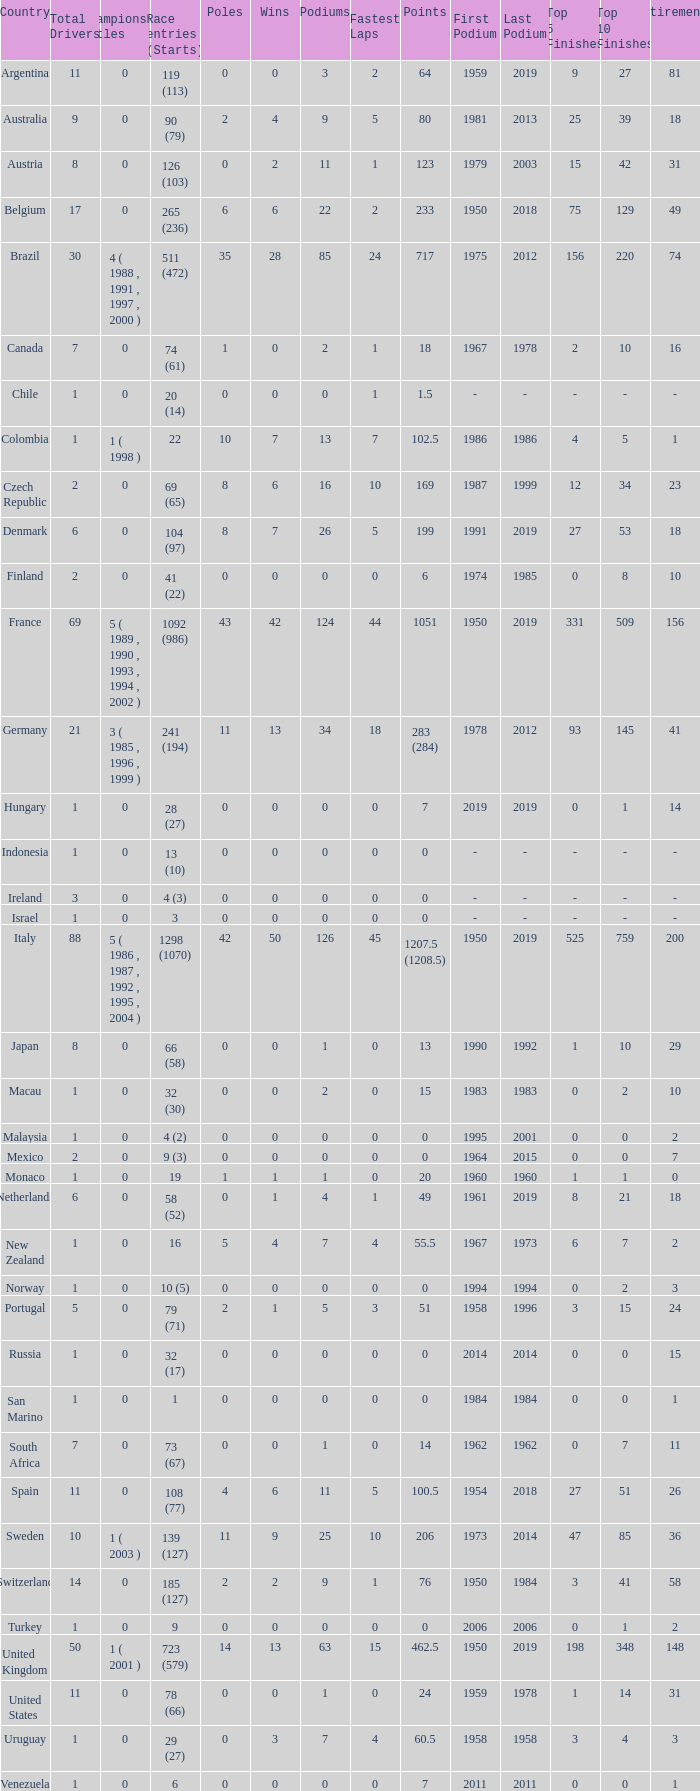How many fastest laps for the nation with 32 (30) entries and starts and fewer than 2 podiums? None. Help me parse the entirety of this table. {'header': ['Country', 'Total Drivers', 'Championship Titles', 'Race entries (Starts)', 'Poles', 'Wins', 'Podiums', 'Fastest Laps', 'Points', 'First Podium', 'Last Podium', 'Top 5 Finishes', 'Top 10 Finishes', 'Retirements'], 'rows': [['Argentina', '11', '0', '119 (113)', '0', '0', '3', '2', '64', '1959', '2019', '9', '27', '81'], ['Australia', '9', '0', '90 (79)', '2', '4', '9', '5', '80', '1981', '2013', '25', '39', '18'], ['Austria', '8', '0', '126 (103)', '0', '2', '11', '1', '123', '1979', '2003', '15', '42', '31'], ['Belgium', '17', '0', '265 (236)', '6', '6', '22', '2', '233', '1950', '2018', '75', '129', '49'], ['Brazil', '30', '4 ( 1988 , 1991 , 1997 , 2000 )', '511 (472)', '35', '28', '85', '24', '717', '1975', '2012', '156', '220', '74'], ['Canada', '7', '0', '74 (61)', '1', '0', '2', '1', '18', '1967', '1978', '2', '10', '16'], ['Chile', '1', '0', '20 (14)', '0', '0', '0', '1', '1.5', '-', '-', '-', '-', '-'], ['Colombia', '1', '1 ( 1998 )', '22', '10', '7', '13', '7', '102.5', '1986', '1986', '4', '5', '1'], ['Czech Republic', '2', '0', '69 (65)', '8', '6', '16', '10', '169', '1987', '1999', '12', '34', '23'], ['Denmark', '6', '0', '104 (97)', '8', '7', '26', '5', '199', '1991', '2019', '27', '53', '18'], ['Finland', '2', '0', '41 (22)', '0', '0', '0', '0', '6', '1974', '1985', '0', '8', '10'], ['France', '69', '5 ( 1989 , 1990 , 1993 , 1994 , 2002 )', '1092 (986)', '43', '42', '124', '44', '1051', '1950', '2019', '331', '509', '156'], ['Germany', '21', '3 ( 1985 , 1996 , 1999 )', '241 (194)', '11', '13', '34', '18', '283 (284)', '1978', '2012', '93', '145', '41'], ['Hungary', '1', '0', '28 (27)', '0', '0', '0', '0', '7', '2019', '2019', '0', '1', '14'], ['Indonesia', '1', '0', '13 (10)', '0', '0', '0', '0', '0', '-', '-', '-', '-', '-'], ['Ireland', '3', '0', '4 (3)', '0', '0', '0', '0', '0', '-', '-', '-', '-', '-'], ['Israel', '1', '0', '3', '0', '0', '0', '0', '0', '-', '-', '-', '-', '-'], ['Italy', '88', '5 ( 1986 , 1987 , 1992 , 1995 , 2004 )', '1298 (1070)', '42', '50', '126', '45', '1207.5 (1208.5)', '1950', '2019', '525', '759', '200'], ['Japan', '8', '0', '66 (58)', '0', '0', '1', '0', '13', '1990', '1992', '1', '10', '29'], ['Macau', '1', '0', '32 (30)', '0', '0', '2', '0', '15', '1983', '1983', '0', '2', '10'], ['Malaysia', '1', '0', '4 (2)', '0', '0', '0', '0', '0', '1995', '2001', '0', '0', '2'], ['Mexico', '2', '0', '9 (3)', '0', '0', '0', '0', '0', '1964', '2015', '0', '0', '7'], ['Monaco', '1', '0', '19', '1', '1', '1', '0', '20', '1960', '1960', '1', '1', '0'], ['Netherlands', '6', '0', '58 (52)', '0', '1', '4', '1', '49', '1961', '2019', '8', '21', '18'], ['New Zealand', '1', '0', '16', '5', '4', '7', '4', '55.5', '1967', '1973', '6', '7', '2'], ['Norway', '1', '0', '10 (5)', '0', '0', '0', '0', '0', '1994', '1994', '0', '2', '3'], ['Portugal', '5', '0', '79 (71)', '2', '1', '5', '3', '51', '1958', '1996', '3', '15', '24'], ['Russia', '1', '0', '32 (17)', '0', '0', '0', '0', '0', '2014', '2014', '0', '0', '15'], ['San Marino', '1', '0', '1', '0', '0', '0', '0', '0', '1984', '1984', '0', '0', '1'], ['South Africa', '7', '0', '73 (67)', '0', '0', '1', '0', '14', '1962', '1962', '0', '7', '11'], ['Spain', '11', '0', '108 (77)', '4', '6', '11', '5', '100.5', '1954', '2018', '27', '51', '26'], ['Sweden', '10', '1 ( 2003 )', '139 (127)', '11', '9', '25', '10', '206', '1973', '2014', '47', '85', '36'], ['Switzerland', '14', '0', '185 (127)', '2', '2', '9', '1', '76', '1950', '1984', '3', '41', '58'], ['Turkey', '1', '0', '9', '0', '0', '0', '0', '0', '2006', '2006', '0', '1', '2'], ['United Kingdom', '50', '1 ( 2001 )', '723 (579)', '14', '13', '63', '15', '462.5', '1950', '2019', '198', '348', '148'], ['United States', '11', '0', '78 (66)', '0', '0', '1', '0', '24', '1959', '1978', '1', '14', '31'], ['Uruguay', '1', '0', '29 (27)', '0', '3', '7', '4', '60.5', '1958', '1958', '3', '4', '3'], ['Venezuela', '1', '0', '6', '0', '0', '0', '0', '7', '2011', '2011', '0', '0', '1']]} 